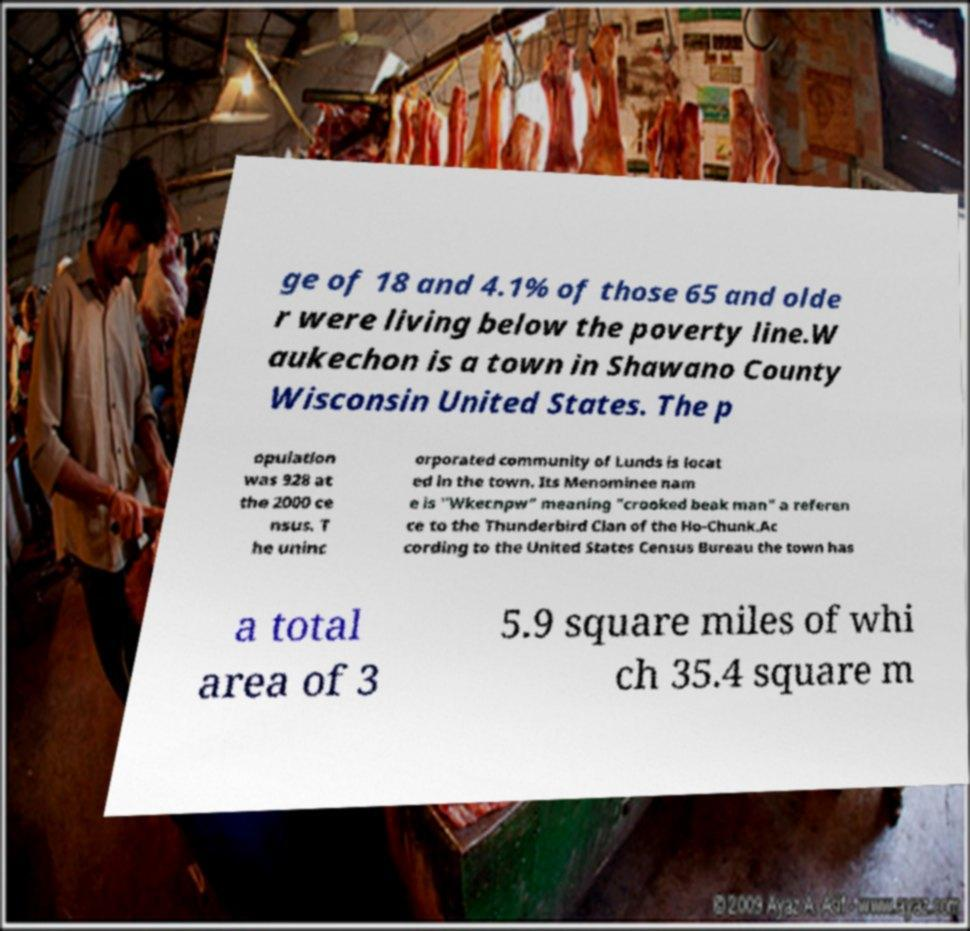Can you accurately transcribe the text from the provided image for me? ge of 18 and 4.1% of those 65 and olde r were living below the poverty line.W aukechon is a town in Shawano County Wisconsin United States. The p opulation was 928 at the 2000 ce nsus. T he uninc orporated community of Lunds is locat ed in the town. Its Menominee nam e is "Wkecnpw" meaning "crooked beak man" a referen ce to the Thunderbird Clan of the Ho-Chunk.Ac cording to the United States Census Bureau the town has a total area of 3 5.9 square miles of whi ch 35.4 square m 